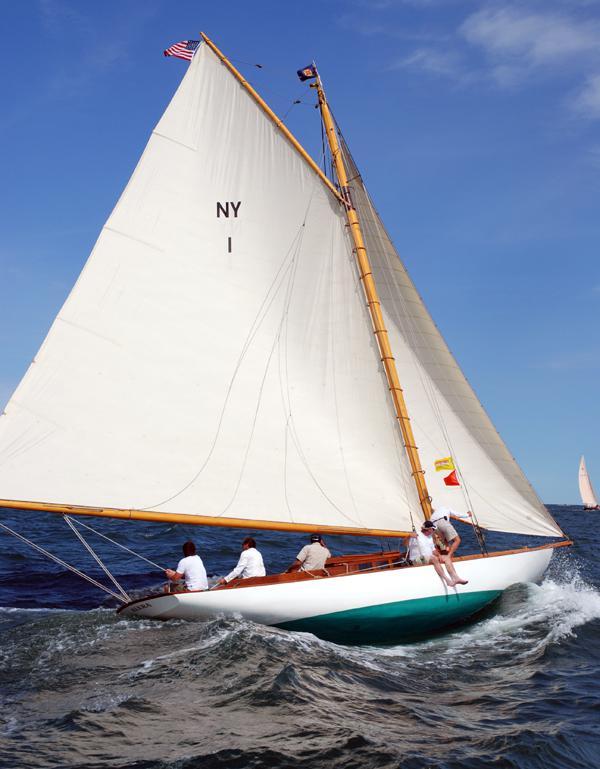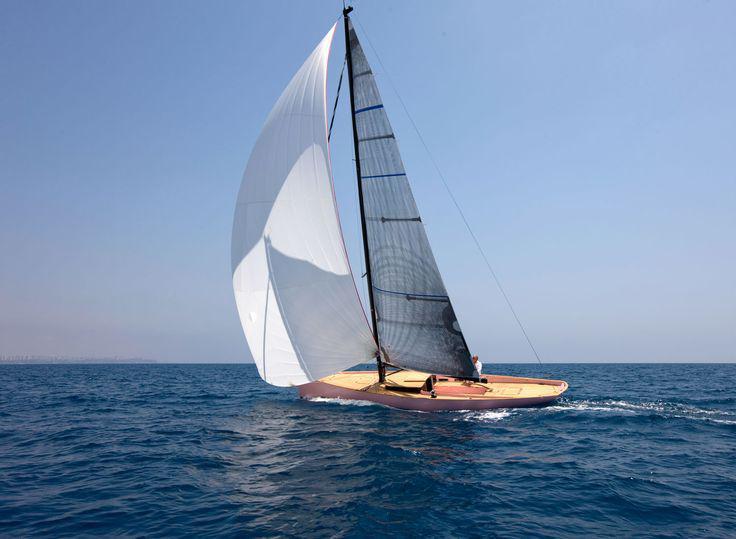The first image is the image on the left, the second image is the image on the right. For the images displayed, is the sentence "All boats are tilted." factually correct? Answer yes or no. Yes. 